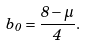<formula> <loc_0><loc_0><loc_500><loc_500>b _ { 0 } = \frac { 8 - \mu } { 4 } .</formula> 